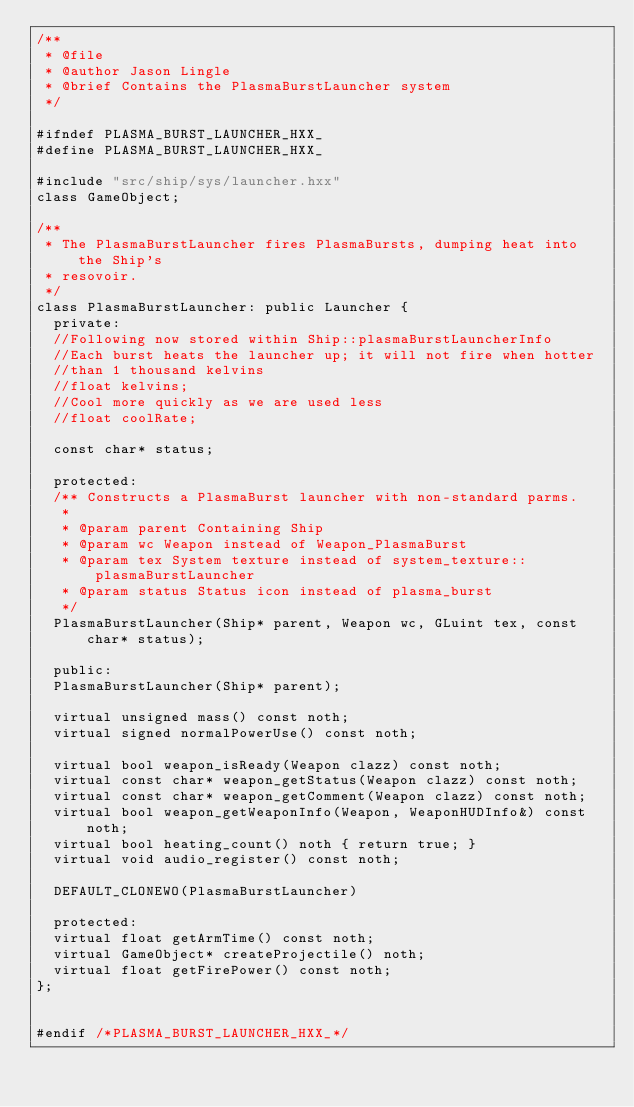<code> <loc_0><loc_0><loc_500><loc_500><_C++_>/**
 * @file
 * @author Jason Lingle
 * @brief Contains the PlasmaBurstLauncher system
 */

#ifndef PLASMA_BURST_LAUNCHER_HXX_
#define PLASMA_BURST_LAUNCHER_HXX_

#include "src/ship/sys/launcher.hxx"
class GameObject;

/**
 * The PlasmaBurstLauncher fires PlasmaBursts, dumping heat into the Ship's
 * resovoir.
 */
class PlasmaBurstLauncher: public Launcher {
  private:
  //Following now stored within Ship::plasmaBurstLauncherInfo
  //Each burst heats the launcher up; it will not fire when hotter
  //than 1 thousand kelvins
  //float kelvins;
  //Cool more quickly as we are used less
  //float coolRate;

  const char* status;

  protected:
  /** Constructs a PlasmaBurst launcher with non-standard parms.
   *
   * @param parent Containing Ship
   * @param wc Weapon instead of Weapon_PlasmaBurst
   * @param tex System texture instead of system_texture::plasmaBurstLauncher
   * @param status Status icon instead of plasma_burst
   */
  PlasmaBurstLauncher(Ship* parent, Weapon wc, GLuint tex, const char* status);

  public:
  PlasmaBurstLauncher(Ship* parent);

  virtual unsigned mass() const noth;
  virtual signed normalPowerUse() const noth;

  virtual bool weapon_isReady(Weapon clazz) const noth;
  virtual const char* weapon_getStatus(Weapon clazz) const noth;
  virtual const char* weapon_getComment(Weapon clazz) const noth;
  virtual bool weapon_getWeaponInfo(Weapon, WeaponHUDInfo&) const noth;
  virtual bool heating_count() noth { return true; }
  virtual void audio_register() const noth;

  DEFAULT_CLONEWO(PlasmaBurstLauncher)

  protected:
  virtual float getArmTime() const noth;
  virtual GameObject* createProjectile() noth;
  virtual float getFirePower() const noth;
};


#endif /*PLASMA_BURST_LAUNCHER_HXX_*/
</code> 